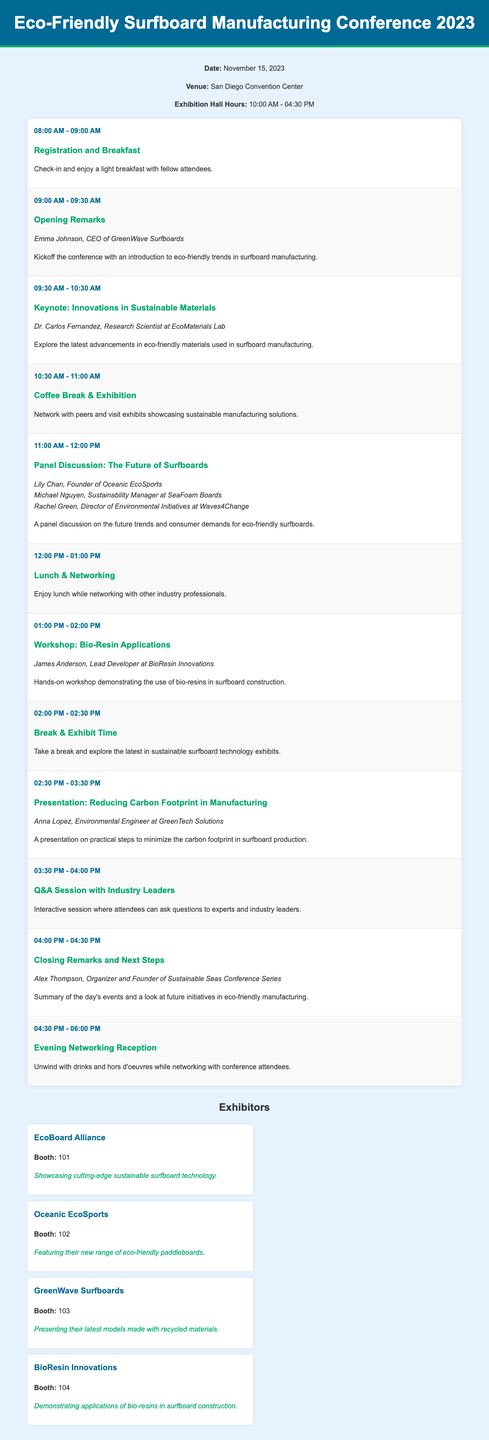What is the date of the conference? The conference is scheduled for November 15, 2023.
Answer: November 15, 2023 Who is the speaker for the keynote session? The keynote session on Innovations in Sustainable Materials is presented by Dr. Carlos Fernandez.
Answer: Dr. Carlos Fernandez What time does the exhibition hall open? The exhibition hall opens at 10:00 AM.
Answer: 10:00 AM How long is the lunch break? Lunch & Networking is scheduled for one hour, from 12:00 PM to 01:00 PM.
Answer: One hour What is the title of the panel discussion? The title of the panel discussion is "The Future of Surfboards."
Answer: The Future of Surfboards Which exhibitor features a new range of eco-friendly paddleboards? Oceanic EcoSports is featuring their new range of eco-friendly paddleboards.
Answer: Oceanic EcoSports What is the purpose of the Coffee Break & Exhibition session? The session is meant for networking with peers and visiting sustainable manufacturing exhibits.
Answer: Networking and visiting exhibits Who will give the closing remarks? The closing remarks will be given by Alex Thompson.
Answer: Alex Thompson What is the time for the Evening Networking Reception? The Evening Networking Reception is from 04:30 PM to 06:00 PM.
Answer: 04:30 PM - 06:00 PM 